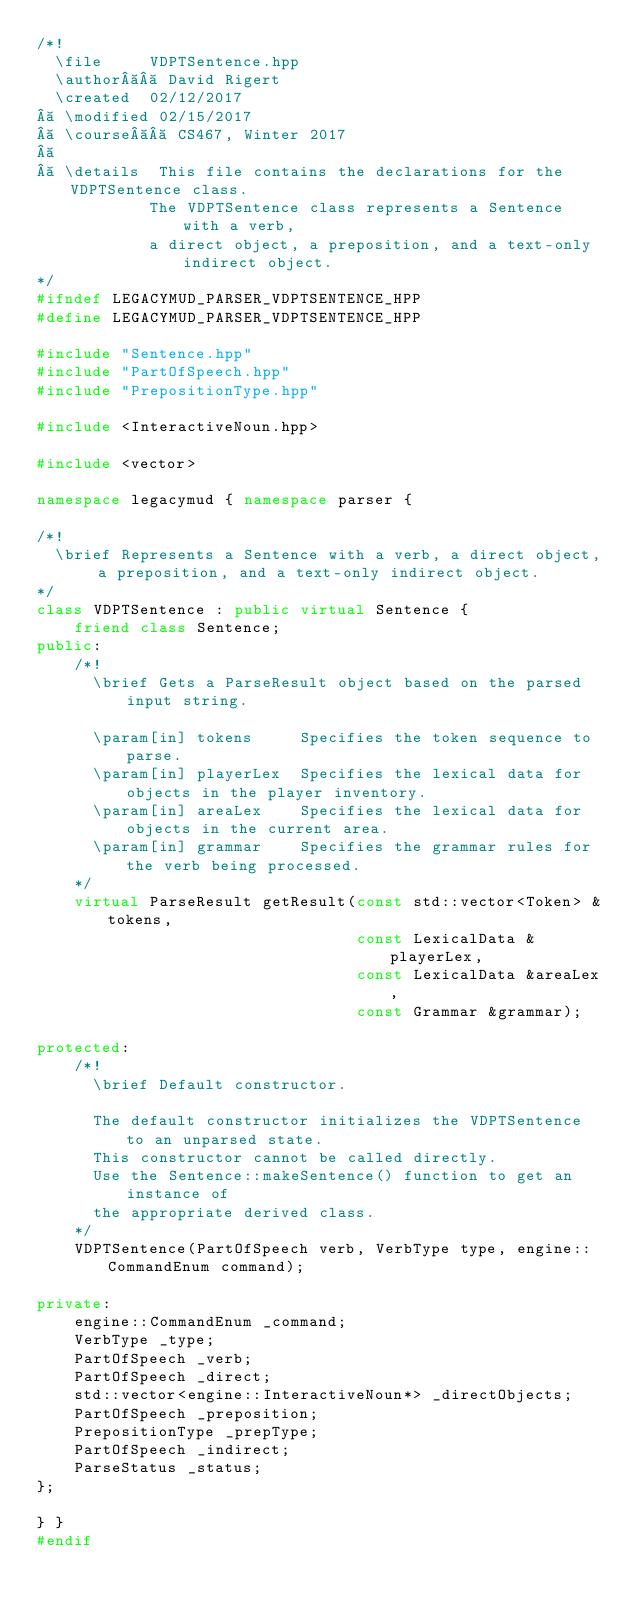Convert code to text. <code><loc_0><loc_0><loc_500><loc_500><_C++_>/*!
  \file     VDPTSentence.hpp
  \author   David Rigert
  \created  02/12/2017
  \modified 02/15/2017
  \course   CS467, Winter 2017
 
  \details  This file contains the declarations for the VDPTSentence class.
            The VDPTSentence class represents a Sentence with a verb,
            a direct object, a preposition, and a text-only indirect object.
*/
#ifndef LEGACYMUD_PARSER_VDPTSENTENCE_HPP
#define LEGACYMUD_PARSER_VDPTSENTENCE_HPP

#include "Sentence.hpp"
#include "PartOfSpeech.hpp"
#include "PrepositionType.hpp"

#include <InteractiveNoun.hpp>

#include <vector>

namespace legacymud { namespace parser {

/*!
  \brief Represents a Sentence with a verb, a direct object, a preposition, and a text-only indirect object.
*/
class VDPTSentence : public virtual Sentence {
    friend class Sentence;
public:
    /*!
      \brief Gets a ParseResult object based on the parsed input string.

      \param[in] tokens     Specifies the token sequence to parse.
      \param[in] playerLex  Specifies the lexical data for objects in the player inventory.
      \param[in] areaLex    Specifies the lexical data for objects in the current area.
      \param[in] grammar    Specifies the grammar rules for the verb being processed.
    */
    virtual ParseResult getResult(const std::vector<Token> &tokens, 
                                  const LexicalData &playerLex, 
                                  const LexicalData &areaLex,
                                  const Grammar &grammar);

protected:
    /*!
      \brief Default constructor.

      The default constructor initializes the VDPTSentence to an unparsed state.
      This constructor cannot be called directly. 
      Use the Sentence::makeSentence() function to get an instance of 
      the appropriate derived class.
    */
    VDPTSentence(PartOfSpeech verb, VerbType type, engine::CommandEnum command);

private:
    engine::CommandEnum _command;
    VerbType _type;
    PartOfSpeech _verb;
    PartOfSpeech _direct;
    std::vector<engine::InteractiveNoun*> _directObjects;
    PartOfSpeech _preposition;
    PrepositionType _prepType;
    PartOfSpeech _indirect;
    ParseStatus _status;
};

} }
#endif
</code> 